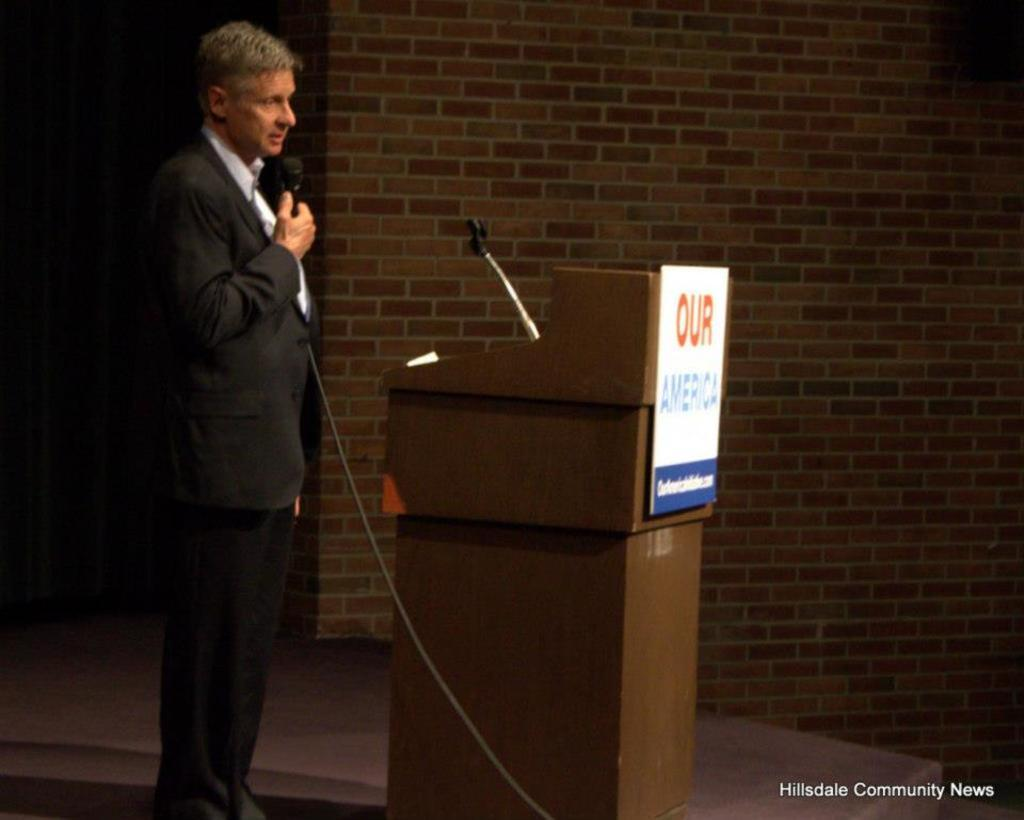<image>
Give a short and clear explanation of the subsequent image. a man in front of an our sign in front of them 